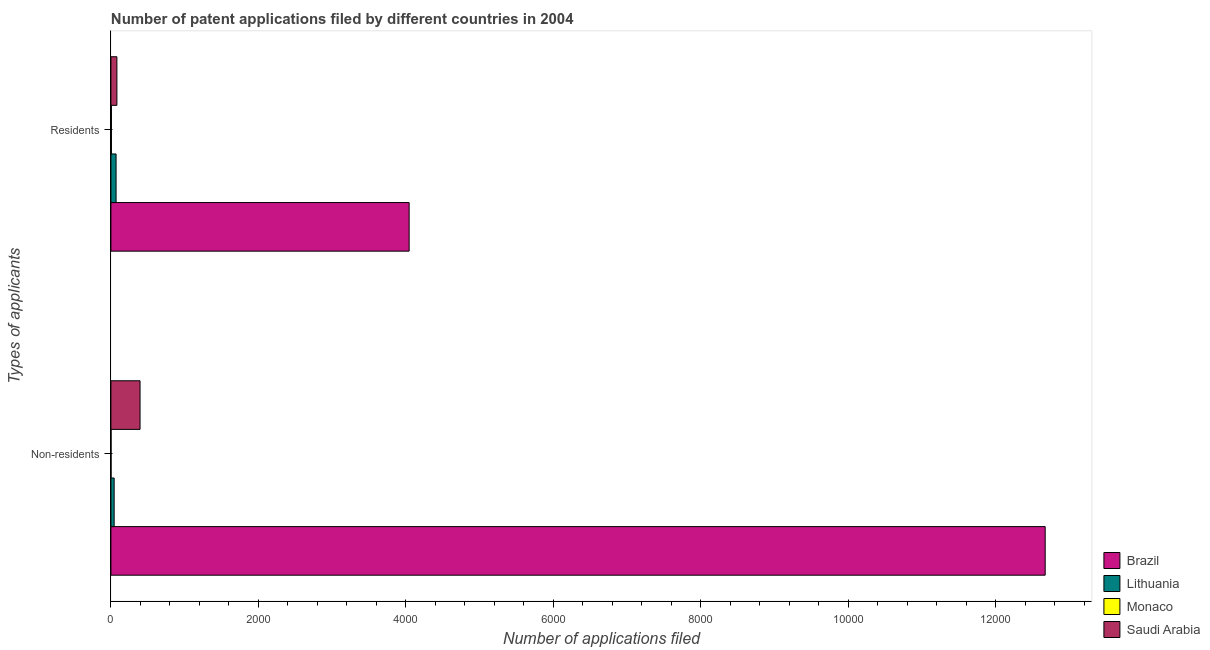Are the number of bars on each tick of the Y-axis equal?
Your answer should be very brief. Yes. What is the label of the 1st group of bars from the top?
Ensure brevity in your answer.  Residents. What is the number of patent applications by residents in Brazil?
Your answer should be compact. 4044. Across all countries, what is the maximum number of patent applications by non residents?
Make the answer very short. 1.27e+04. Across all countries, what is the minimum number of patent applications by residents?
Provide a succinct answer. 7. In which country was the number of patent applications by non residents minimum?
Your response must be concise. Monaco. What is the total number of patent applications by residents in the graph?
Make the answer very short. 4202. What is the difference between the number of patent applications by residents in Brazil and that in Monaco?
Your answer should be compact. 4037. What is the difference between the number of patent applications by non residents in Saudi Arabia and the number of patent applications by residents in Monaco?
Ensure brevity in your answer.  388. What is the average number of patent applications by residents per country?
Ensure brevity in your answer.  1050.5. What is the difference between the number of patent applications by residents and number of patent applications by non residents in Saudi Arabia?
Offer a terse response. -314. In how many countries, is the number of patent applications by residents greater than 12000 ?
Your answer should be very brief. 0. What is the ratio of the number of patent applications by residents in Saudi Arabia to that in Lithuania?
Keep it short and to the point. 1.16. Is the number of patent applications by residents in Lithuania less than that in Brazil?
Provide a succinct answer. Yes. In how many countries, is the number of patent applications by residents greater than the average number of patent applications by residents taken over all countries?
Your response must be concise. 1. What does the 2nd bar from the top in Non-residents represents?
Offer a terse response. Monaco. What does the 4th bar from the bottom in Residents represents?
Your answer should be very brief. Saudi Arabia. Are all the bars in the graph horizontal?
Ensure brevity in your answer.  Yes. How many countries are there in the graph?
Provide a short and direct response. 4. What is the difference between two consecutive major ticks on the X-axis?
Your answer should be compact. 2000. Are the values on the major ticks of X-axis written in scientific E-notation?
Your answer should be very brief. No. Does the graph contain grids?
Ensure brevity in your answer.  No. Where does the legend appear in the graph?
Your response must be concise. Bottom right. How many legend labels are there?
Keep it short and to the point. 4. How are the legend labels stacked?
Your answer should be very brief. Vertical. What is the title of the graph?
Your answer should be very brief. Number of patent applications filed by different countries in 2004. What is the label or title of the X-axis?
Offer a very short reply. Number of applications filed. What is the label or title of the Y-axis?
Ensure brevity in your answer.  Types of applicants. What is the Number of applications filed of Brazil in Non-residents?
Offer a terse response. 1.27e+04. What is the Number of applications filed of Lithuania in Non-residents?
Your response must be concise. 44. What is the Number of applications filed in Monaco in Non-residents?
Ensure brevity in your answer.  2. What is the Number of applications filed in Saudi Arabia in Non-residents?
Ensure brevity in your answer.  395. What is the Number of applications filed of Brazil in Residents?
Your answer should be very brief. 4044. What is the Number of applications filed in Monaco in Residents?
Your answer should be compact. 7. What is the Number of applications filed of Saudi Arabia in Residents?
Provide a succinct answer. 81. Across all Types of applicants, what is the maximum Number of applications filed in Brazil?
Ensure brevity in your answer.  1.27e+04. Across all Types of applicants, what is the maximum Number of applications filed in Lithuania?
Provide a succinct answer. 70. Across all Types of applicants, what is the maximum Number of applications filed of Monaco?
Your response must be concise. 7. Across all Types of applicants, what is the maximum Number of applications filed in Saudi Arabia?
Make the answer very short. 395. Across all Types of applicants, what is the minimum Number of applications filed of Brazil?
Your answer should be very brief. 4044. Across all Types of applicants, what is the minimum Number of applications filed of Lithuania?
Make the answer very short. 44. Across all Types of applicants, what is the minimum Number of applications filed of Monaco?
Offer a very short reply. 2. Across all Types of applicants, what is the minimum Number of applications filed in Saudi Arabia?
Offer a very short reply. 81. What is the total Number of applications filed in Brazil in the graph?
Ensure brevity in your answer.  1.67e+04. What is the total Number of applications filed in Lithuania in the graph?
Offer a terse response. 114. What is the total Number of applications filed of Saudi Arabia in the graph?
Your response must be concise. 476. What is the difference between the Number of applications filed of Brazil in Non-residents and that in Residents?
Keep it short and to the point. 8625. What is the difference between the Number of applications filed in Saudi Arabia in Non-residents and that in Residents?
Give a very brief answer. 314. What is the difference between the Number of applications filed of Brazil in Non-residents and the Number of applications filed of Lithuania in Residents?
Your response must be concise. 1.26e+04. What is the difference between the Number of applications filed of Brazil in Non-residents and the Number of applications filed of Monaco in Residents?
Provide a succinct answer. 1.27e+04. What is the difference between the Number of applications filed of Brazil in Non-residents and the Number of applications filed of Saudi Arabia in Residents?
Make the answer very short. 1.26e+04. What is the difference between the Number of applications filed in Lithuania in Non-residents and the Number of applications filed in Monaco in Residents?
Offer a very short reply. 37. What is the difference between the Number of applications filed in Lithuania in Non-residents and the Number of applications filed in Saudi Arabia in Residents?
Your answer should be compact. -37. What is the difference between the Number of applications filed of Monaco in Non-residents and the Number of applications filed of Saudi Arabia in Residents?
Provide a short and direct response. -79. What is the average Number of applications filed in Brazil per Types of applicants?
Provide a short and direct response. 8356.5. What is the average Number of applications filed of Monaco per Types of applicants?
Your answer should be compact. 4.5. What is the average Number of applications filed of Saudi Arabia per Types of applicants?
Provide a succinct answer. 238. What is the difference between the Number of applications filed in Brazil and Number of applications filed in Lithuania in Non-residents?
Your response must be concise. 1.26e+04. What is the difference between the Number of applications filed of Brazil and Number of applications filed of Monaco in Non-residents?
Provide a succinct answer. 1.27e+04. What is the difference between the Number of applications filed in Brazil and Number of applications filed in Saudi Arabia in Non-residents?
Give a very brief answer. 1.23e+04. What is the difference between the Number of applications filed of Lithuania and Number of applications filed of Monaco in Non-residents?
Offer a terse response. 42. What is the difference between the Number of applications filed of Lithuania and Number of applications filed of Saudi Arabia in Non-residents?
Make the answer very short. -351. What is the difference between the Number of applications filed in Monaco and Number of applications filed in Saudi Arabia in Non-residents?
Offer a very short reply. -393. What is the difference between the Number of applications filed in Brazil and Number of applications filed in Lithuania in Residents?
Make the answer very short. 3974. What is the difference between the Number of applications filed in Brazil and Number of applications filed in Monaco in Residents?
Your response must be concise. 4037. What is the difference between the Number of applications filed of Brazil and Number of applications filed of Saudi Arabia in Residents?
Ensure brevity in your answer.  3963. What is the difference between the Number of applications filed of Lithuania and Number of applications filed of Monaco in Residents?
Your response must be concise. 63. What is the difference between the Number of applications filed in Monaco and Number of applications filed in Saudi Arabia in Residents?
Keep it short and to the point. -74. What is the ratio of the Number of applications filed in Brazil in Non-residents to that in Residents?
Offer a terse response. 3.13. What is the ratio of the Number of applications filed of Lithuania in Non-residents to that in Residents?
Your answer should be compact. 0.63. What is the ratio of the Number of applications filed of Monaco in Non-residents to that in Residents?
Offer a terse response. 0.29. What is the ratio of the Number of applications filed of Saudi Arabia in Non-residents to that in Residents?
Make the answer very short. 4.88. What is the difference between the highest and the second highest Number of applications filed in Brazil?
Ensure brevity in your answer.  8625. What is the difference between the highest and the second highest Number of applications filed in Lithuania?
Keep it short and to the point. 26. What is the difference between the highest and the second highest Number of applications filed of Saudi Arabia?
Your answer should be very brief. 314. What is the difference between the highest and the lowest Number of applications filed of Brazil?
Give a very brief answer. 8625. What is the difference between the highest and the lowest Number of applications filed of Monaco?
Your answer should be compact. 5. What is the difference between the highest and the lowest Number of applications filed in Saudi Arabia?
Your answer should be very brief. 314. 